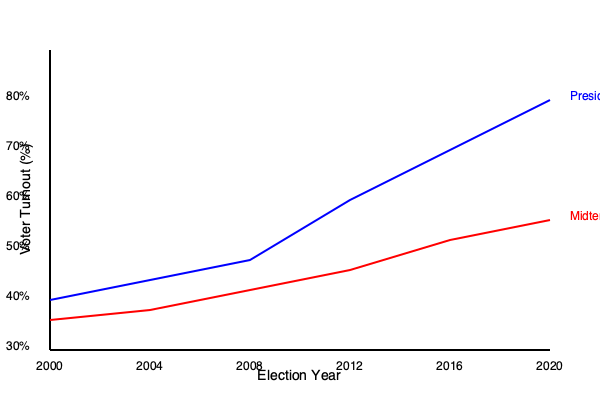Based on the voter turnout trends shown in the graph for Bexar County, calculate the average difference in turnout percentage between presidential and midterm elections over the period from 2000 to 2020. What does this difference suggest about voter engagement in local politics? To solve this problem, we need to follow these steps:

1. Identify the turnout percentages for presidential and midterm elections:

   Presidential:
   2000: 40%
   2004: 42%
   2008: 44%
   2012: 55%
   2016: 65%
   2020: 75%

   Midterm:
   2002: 36%
   2006: 38%
   2010: 41%
   2014: 45%
   2018: 52%

2. Calculate the difference for each pair of elections:

   2000-2002: 40% - 36% = 4%
   2004-2006: 42% - 38% = 4%
   2008-2010: 44% - 41% = 3%
   2012-2014: 55% - 45% = 10%
   2016-2018: 65% - 52% = 13%

3. Calculate the average difference:

   $\text{Average Difference} = \frac{4\% + 4\% + 3\% + 10\% + 13\%}{5} = \frac{34\%}{5} = 6.8\%$

4. Interpret the result:
   The average difference of 6.8% suggests a significant gap in voter engagement between presidential and midterm elections. This indicates that:

   a) Voters in Bexar County are more motivated to participate in presidential elections.
   b) There is less interest or awareness in local and state-level politics during midterm elections.
   c) There might be a need for increased voter education and outreach efforts to boost midterm election turnout.
   d) The trend shows an increasing gap over time, suggesting growing polarization or focus on national politics at the expense of local engagement.

This analysis provides insights into voter behavior and could inform strategies for increasing civic participation in local politics.
Answer: 6.8%; suggests lower engagement in local politics during midterms 